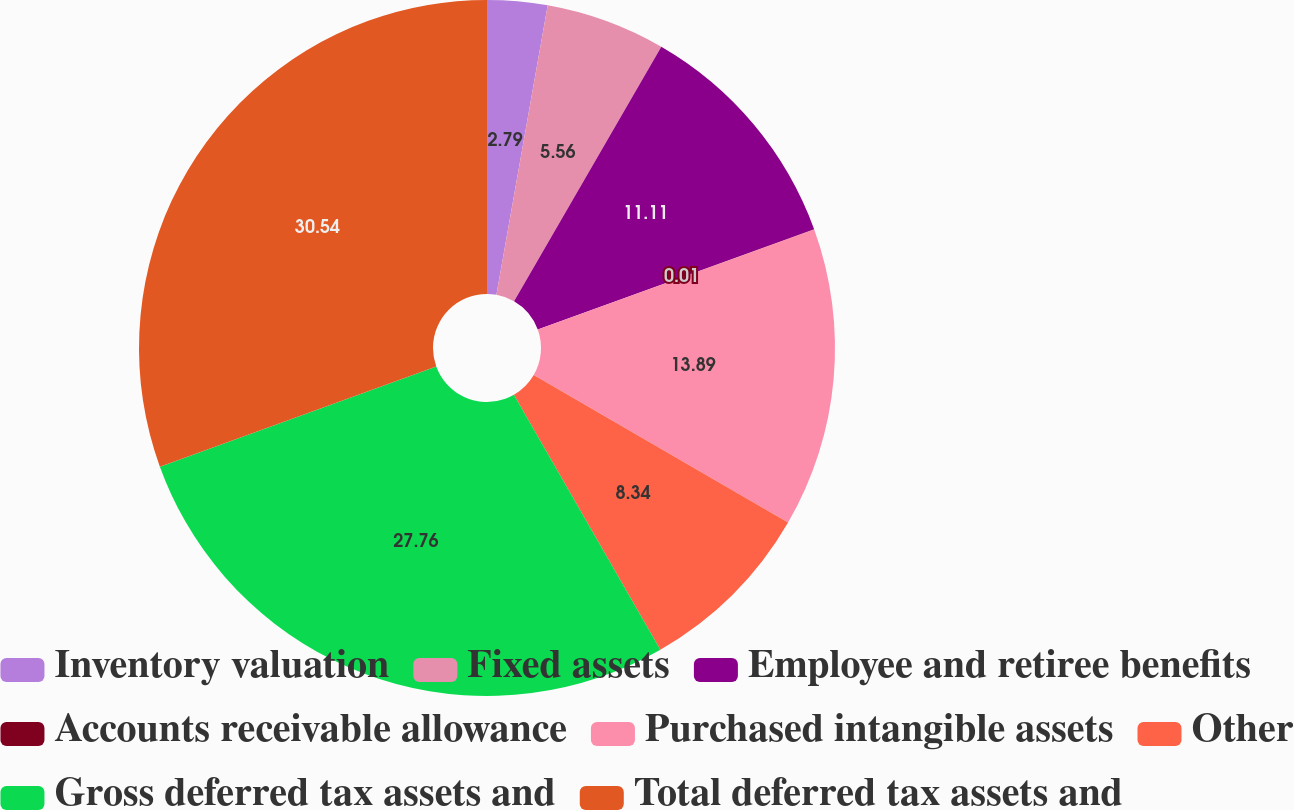Convert chart. <chart><loc_0><loc_0><loc_500><loc_500><pie_chart><fcel>Inventory valuation<fcel>Fixed assets<fcel>Employee and retiree benefits<fcel>Accounts receivable allowance<fcel>Purchased intangible assets<fcel>Other<fcel>Gross deferred tax assets and<fcel>Total deferred tax assets and<nl><fcel>2.79%<fcel>5.56%<fcel>11.11%<fcel>0.01%<fcel>13.89%<fcel>8.34%<fcel>27.76%<fcel>30.54%<nl></chart> 